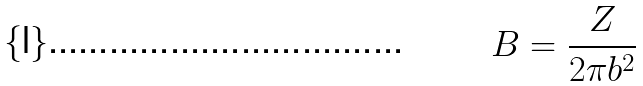Convert formula to latex. <formula><loc_0><loc_0><loc_500><loc_500>B = \frac { Z } { 2 \pi b ^ { 2 } }</formula> 